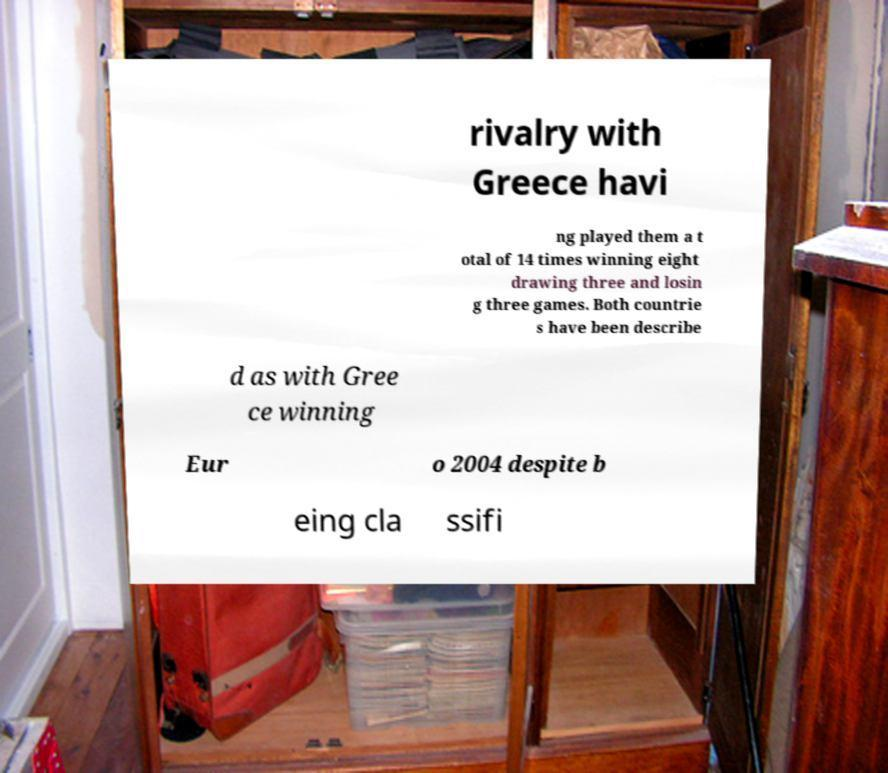Please identify and transcribe the text found in this image. rivalry with Greece havi ng played them a t otal of 14 times winning eight drawing three and losin g three games. Both countrie s have been describe d as with Gree ce winning Eur o 2004 despite b eing cla ssifi 